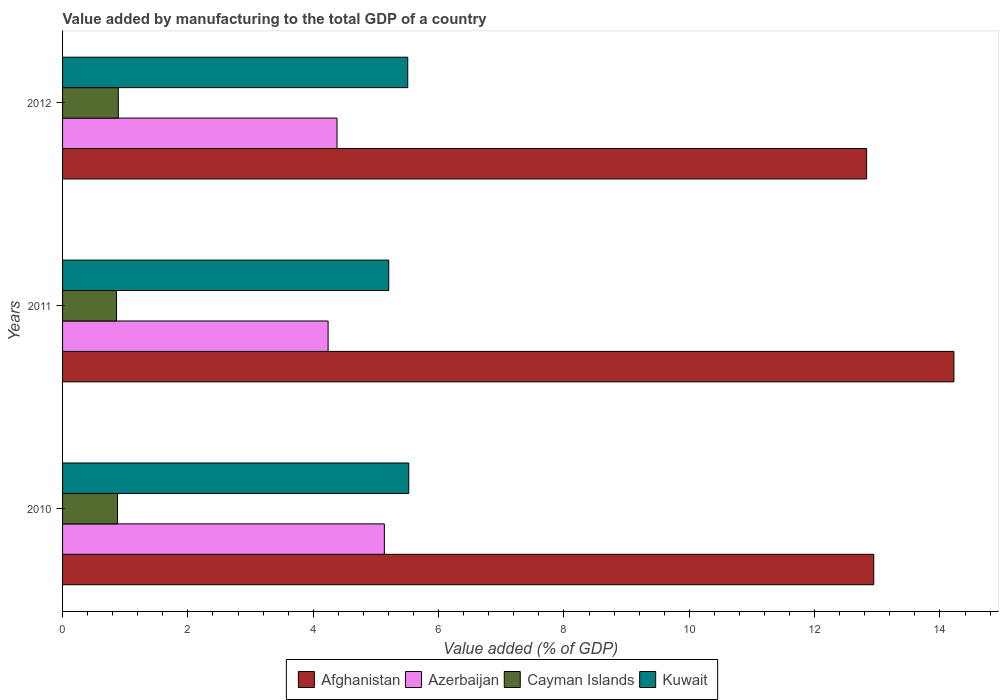How many different coloured bars are there?
Your answer should be very brief. 4. How many groups of bars are there?
Your answer should be very brief. 3. Are the number of bars per tick equal to the number of legend labels?
Your answer should be compact. Yes. Are the number of bars on each tick of the Y-axis equal?
Offer a terse response. Yes. How many bars are there on the 3rd tick from the top?
Give a very brief answer. 4. What is the label of the 1st group of bars from the top?
Provide a succinct answer. 2012. In how many cases, is the number of bars for a given year not equal to the number of legend labels?
Provide a succinct answer. 0. What is the value added by manufacturing to the total GDP in Cayman Islands in 2011?
Your response must be concise. 0.86. Across all years, what is the maximum value added by manufacturing to the total GDP in Kuwait?
Keep it short and to the point. 5.52. Across all years, what is the minimum value added by manufacturing to the total GDP in Kuwait?
Ensure brevity in your answer.  5.2. In which year was the value added by manufacturing to the total GDP in Cayman Islands maximum?
Give a very brief answer. 2012. What is the total value added by manufacturing to the total GDP in Azerbaijan in the graph?
Make the answer very short. 13.75. What is the difference between the value added by manufacturing to the total GDP in Cayman Islands in 2011 and that in 2012?
Your response must be concise. -0.03. What is the difference between the value added by manufacturing to the total GDP in Afghanistan in 2011 and the value added by manufacturing to the total GDP in Azerbaijan in 2012?
Offer a very short reply. 9.84. What is the average value added by manufacturing to the total GDP in Kuwait per year?
Provide a short and direct response. 5.41. In the year 2012, what is the difference between the value added by manufacturing to the total GDP in Afghanistan and value added by manufacturing to the total GDP in Cayman Islands?
Your answer should be very brief. 11.94. What is the ratio of the value added by manufacturing to the total GDP in Azerbaijan in 2010 to that in 2011?
Your answer should be compact. 1.21. Is the value added by manufacturing to the total GDP in Azerbaijan in 2010 less than that in 2012?
Provide a succinct answer. No. What is the difference between the highest and the second highest value added by manufacturing to the total GDP in Cayman Islands?
Make the answer very short. 0.01. What is the difference between the highest and the lowest value added by manufacturing to the total GDP in Kuwait?
Your answer should be very brief. 0.32. In how many years, is the value added by manufacturing to the total GDP in Kuwait greater than the average value added by manufacturing to the total GDP in Kuwait taken over all years?
Your answer should be compact. 2. Is it the case that in every year, the sum of the value added by manufacturing to the total GDP in Cayman Islands and value added by manufacturing to the total GDP in Kuwait is greater than the sum of value added by manufacturing to the total GDP in Afghanistan and value added by manufacturing to the total GDP in Azerbaijan?
Offer a terse response. Yes. What does the 3rd bar from the top in 2010 represents?
Your answer should be compact. Azerbaijan. What does the 3rd bar from the bottom in 2010 represents?
Your answer should be compact. Cayman Islands. Are all the bars in the graph horizontal?
Your answer should be compact. Yes. What is the difference between two consecutive major ticks on the X-axis?
Provide a short and direct response. 2. Are the values on the major ticks of X-axis written in scientific E-notation?
Your answer should be compact. No. Where does the legend appear in the graph?
Give a very brief answer. Bottom center. How are the legend labels stacked?
Your answer should be compact. Horizontal. What is the title of the graph?
Your response must be concise. Value added by manufacturing to the total GDP of a country. Does "Saudi Arabia" appear as one of the legend labels in the graph?
Your answer should be compact. No. What is the label or title of the X-axis?
Provide a short and direct response. Value added (% of GDP). What is the label or title of the Y-axis?
Your answer should be compact. Years. What is the Value added (% of GDP) in Afghanistan in 2010?
Offer a terse response. 12.94. What is the Value added (% of GDP) in Azerbaijan in 2010?
Your answer should be compact. 5.13. What is the Value added (% of GDP) of Cayman Islands in 2010?
Offer a terse response. 0.88. What is the Value added (% of GDP) in Kuwait in 2010?
Give a very brief answer. 5.52. What is the Value added (% of GDP) of Afghanistan in 2011?
Keep it short and to the point. 14.22. What is the Value added (% of GDP) of Azerbaijan in 2011?
Your response must be concise. 4.24. What is the Value added (% of GDP) in Cayman Islands in 2011?
Your answer should be compact. 0.86. What is the Value added (% of GDP) of Kuwait in 2011?
Offer a very short reply. 5.2. What is the Value added (% of GDP) in Afghanistan in 2012?
Your answer should be compact. 12.83. What is the Value added (% of GDP) of Azerbaijan in 2012?
Offer a terse response. 4.38. What is the Value added (% of GDP) of Cayman Islands in 2012?
Offer a terse response. 0.89. What is the Value added (% of GDP) of Kuwait in 2012?
Provide a short and direct response. 5.51. Across all years, what is the maximum Value added (% of GDP) of Afghanistan?
Keep it short and to the point. 14.22. Across all years, what is the maximum Value added (% of GDP) in Azerbaijan?
Provide a succinct answer. 5.13. Across all years, what is the maximum Value added (% of GDP) in Cayman Islands?
Your response must be concise. 0.89. Across all years, what is the maximum Value added (% of GDP) in Kuwait?
Ensure brevity in your answer.  5.52. Across all years, what is the minimum Value added (% of GDP) in Afghanistan?
Keep it short and to the point. 12.83. Across all years, what is the minimum Value added (% of GDP) in Azerbaijan?
Your answer should be compact. 4.24. Across all years, what is the minimum Value added (% of GDP) of Cayman Islands?
Provide a succinct answer. 0.86. Across all years, what is the minimum Value added (% of GDP) of Kuwait?
Offer a terse response. 5.2. What is the total Value added (% of GDP) in Afghanistan in the graph?
Your answer should be very brief. 40. What is the total Value added (% of GDP) of Azerbaijan in the graph?
Your answer should be very brief. 13.75. What is the total Value added (% of GDP) in Cayman Islands in the graph?
Provide a short and direct response. 2.63. What is the total Value added (% of GDP) in Kuwait in the graph?
Offer a terse response. 16.24. What is the difference between the Value added (% of GDP) of Afghanistan in 2010 and that in 2011?
Provide a succinct answer. -1.28. What is the difference between the Value added (% of GDP) in Azerbaijan in 2010 and that in 2011?
Your response must be concise. 0.9. What is the difference between the Value added (% of GDP) in Cayman Islands in 2010 and that in 2011?
Ensure brevity in your answer.  0.02. What is the difference between the Value added (% of GDP) of Kuwait in 2010 and that in 2011?
Your answer should be very brief. 0.32. What is the difference between the Value added (% of GDP) in Afghanistan in 2010 and that in 2012?
Your response must be concise. 0.11. What is the difference between the Value added (% of GDP) of Azerbaijan in 2010 and that in 2012?
Your answer should be very brief. 0.76. What is the difference between the Value added (% of GDP) in Cayman Islands in 2010 and that in 2012?
Your answer should be compact. -0.01. What is the difference between the Value added (% of GDP) of Kuwait in 2010 and that in 2012?
Your answer should be very brief. 0.02. What is the difference between the Value added (% of GDP) in Afghanistan in 2011 and that in 2012?
Provide a succinct answer. 1.39. What is the difference between the Value added (% of GDP) of Azerbaijan in 2011 and that in 2012?
Provide a short and direct response. -0.14. What is the difference between the Value added (% of GDP) in Cayman Islands in 2011 and that in 2012?
Offer a very short reply. -0.03. What is the difference between the Value added (% of GDP) of Kuwait in 2011 and that in 2012?
Offer a terse response. -0.3. What is the difference between the Value added (% of GDP) in Afghanistan in 2010 and the Value added (% of GDP) in Azerbaijan in 2011?
Offer a very short reply. 8.71. What is the difference between the Value added (% of GDP) of Afghanistan in 2010 and the Value added (% of GDP) of Cayman Islands in 2011?
Ensure brevity in your answer.  12.08. What is the difference between the Value added (% of GDP) in Afghanistan in 2010 and the Value added (% of GDP) in Kuwait in 2011?
Offer a terse response. 7.74. What is the difference between the Value added (% of GDP) of Azerbaijan in 2010 and the Value added (% of GDP) of Cayman Islands in 2011?
Your response must be concise. 4.27. What is the difference between the Value added (% of GDP) of Azerbaijan in 2010 and the Value added (% of GDP) of Kuwait in 2011?
Ensure brevity in your answer.  -0.07. What is the difference between the Value added (% of GDP) of Cayman Islands in 2010 and the Value added (% of GDP) of Kuwait in 2011?
Your response must be concise. -4.33. What is the difference between the Value added (% of GDP) in Afghanistan in 2010 and the Value added (% of GDP) in Azerbaijan in 2012?
Offer a terse response. 8.56. What is the difference between the Value added (% of GDP) in Afghanistan in 2010 and the Value added (% of GDP) in Cayman Islands in 2012?
Make the answer very short. 12.05. What is the difference between the Value added (% of GDP) of Afghanistan in 2010 and the Value added (% of GDP) of Kuwait in 2012?
Your response must be concise. 7.44. What is the difference between the Value added (% of GDP) in Azerbaijan in 2010 and the Value added (% of GDP) in Cayman Islands in 2012?
Give a very brief answer. 4.25. What is the difference between the Value added (% of GDP) in Azerbaijan in 2010 and the Value added (% of GDP) in Kuwait in 2012?
Provide a short and direct response. -0.37. What is the difference between the Value added (% of GDP) of Cayman Islands in 2010 and the Value added (% of GDP) of Kuwait in 2012?
Your answer should be compact. -4.63. What is the difference between the Value added (% of GDP) of Afghanistan in 2011 and the Value added (% of GDP) of Azerbaijan in 2012?
Your response must be concise. 9.84. What is the difference between the Value added (% of GDP) of Afghanistan in 2011 and the Value added (% of GDP) of Cayman Islands in 2012?
Offer a terse response. 13.33. What is the difference between the Value added (% of GDP) in Afghanistan in 2011 and the Value added (% of GDP) in Kuwait in 2012?
Provide a short and direct response. 8.71. What is the difference between the Value added (% of GDP) of Azerbaijan in 2011 and the Value added (% of GDP) of Cayman Islands in 2012?
Ensure brevity in your answer.  3.35. What is the difference between the Value added (% of GDP) of Azerbaijan in 2011 and the Value added (% of GDP) of Kuwait in 2012?
Keep it short and to the point. -1.27. What is the difference between the Value added (% of GDP) of Cayman Islands in 2011 and the Value added (% of GDP) of Kuwait in 2012?
Keep it short and to the point. -4.65. What is the average Value added (% of GDP) of Afghanistan per year?
Provide a short and direct response. 13.33. What is the average Value added (% of GDP) of Azerbaijan per year?
Your answer should be very brief. 4.58. What is the average Value added (% of GDP) of Cayman Islands per year?
Ensure brevity in your answer.  0.88. What is the average Value added (% of GDP) in Kuwait per year?
Your response must be concise. 5.41. In the year 2010, what is the difference between the Value added (% of GDP) in Afghanistan and Value added (% of GDP) in Azerbaijan?
Your response must be concise. 7.81. In the year 2010, what is the difference between the Value added (% of GDP) in Afghanistan and Value added (% of GDP) in Cayman Islands?
Offer a very short reply. 12.07. In the year 2010, what is the difference between the Value added (% of GDP) of Afghanistan and Value added (% of GDP) of Kuwait?
Your response must be concise. 7.42. In the year 2010, what is the difference between the Value added (% of GDP) of Azerbaijan and Value added (% of GDP) of Cayman Islands?
Give a very brief answer. 4.26. In the year 2010, what is the difference between the Value added (% of GDP) of Azerbaijan and Value added (% of GDP) of Kuwait?
Ensure brevity in your answer.  -0.39. In the year 2010, what is the difference between the Value added (% of GDP) in Cayman Islands and Value added (% of GDP) in Kuwait?
Provide a succinct answer. -4.65. In the year 2011, what is the difference between the Value added (% of GDP) of Afghanistan and Value added (% of GDP) of Azerbaijan?
Keep it short and to the point. 9.99. In the year 2011, what is the difference between the Value added (% of GDP) of Afghanistan and Value added (% of GDP) of Cayman Islands?
Provide a succinct answer. 13.36. In the year 2011, what is the difference between the Value added (% of GDP) in Afghanistan and Value added (% of GDP) in Kuwait?
Provide a succinct answer. 9.02. In the year 2011, what is the difference between the Value added (% of GDP) of Azerbaijan and Value added (% of GDP) of Cayman Islands?
Provide a short and direct response. 3.38. In the year 2011, what is the difference between the Value added (% of GDP) in Azerbaijan and Value added (% of GDP) in Kuwait?
Ensure brevity in your answer.  -0.97. In the year 2011, what is the difference between the Value added (% of GDP) in Cayman Islands and Value added (% of GDP) in Kuwait?
Give a very brief answer. -4.34. In the year 2012, what is the difference between the Value added (% of GDP) of Afghanistan and Value added (% of GDP) of Azerbaijan?
Provide a succinct answer. 8.45. In the year 2012, what is the difference between the Value added (% of GDP) in Afghanistan and Value added (% of GDP) in Cayman Islands?
Offer a terse response. 11.94. In the year 2012, what is the difference between the Value added (% of GDP) in Afghanistan and Value added (% of GDP) in Kuwait?
Provide a short and direct response. 7.32. In the year 2012, what is the difference between the Value added (% of GDP) in Azerbaijan and Value added (% of GDP) in Cayman Islands?
Provide a succinct answer. 3.49. In the year 2012, what is the difference between the Value added (% of GDP) in Azerbaijan and Value added (% of GDP) in Kuwait?
Ensure brevity in your answer.  -1.13. In the year 2012, what is the difference between the Value added (% of GDP) of Cayman Islands and Value added (% of GDP) of Kuwait?
Your answer should be compact. -4.62. What is the ratio of the Value added (% of GDP) of Afghanistan in 2010 to that in 2011?
Your answer should be compact. 0.91. What is the ratio of the Value added (% of GDP) in Azerbaijan in 2010 to that in 2011?
Keep it short and to the point. 1.21. What is the ratio of the Value added (% of GDP) in Cayman Islands in 2010 to that in 2011?
Your response must be concise. 1.02. What is the ratio of the Value added (% of GDP) of Kuwait in 2010 to that in 2011?
Your answer should be compact. 1.06. What is the ratio of the Value added (% of GDP) in Afghanistan in 2010 to that in 2012?
Offer a very short reply. 1.01. What is the ratio of the Value added (% of GDP) of Azerbaijan in 2010 to that in 2012?
Keep it short and to the point. 1.17. What is the ratio of the Value added (% of GDP) of Cayman Islands in 2010 to that in 2012?
Offer a terse response. 0.99. What is the ratio of the Value added (% of GDP) in Kuwait in 2010 to that in 2012?
Provide a short and direct response. 1. What is the ratio of the Value added (% of GDP) of Afghanistan in 2011 to that in 2012?
Ensure brevity in your answer.  1.11. What is the ratio of the Value added (% of GDP) of Azerbaijan in 2011 to that in 2012?
Your response must be concise. 0.97. What is the ratio of the Value added (% of GDP) in Cayman Islands in 2011 to that in 2012?
Give a very brief answer. 0.97. What is the ratio of the Value added (% of GDP) of Kuwait in 2011 to that in 2012?
Keep it short and to the point. 0.94. What is the difference between the highest and the second highest Value added (% of GDP) of Afghanistan?
Provide a short and direct response. 1.28. What is the difference between the highest and the second highest Value added (% of GDP) in Azerbaijan?
Provide a succinct answer. 0.76. What is the difference between the highest and the second highest Value added (% of GDP) of Cayman Islands?
Your answer should be very brief. 0.01. What is the difference between the highest and the second highest Value added (% of GDP) in Kuwait?
Give a very brief answer. 0.02. What is the difference between the highest and the lowest Value added (% of GDP) of Afghanistan?
Keep it short and to the point. 1.39. What is the difference between the highest and the lowest Value added (% of GDP) of Azerbaijan?
Give a very brief answer. 0.9. What is the difference between the highest and the lowest Value added (% of GDP) of Cayman Islands?
Your answer should be very brief. 0.03. What is the difference between the highest and the lowest Value added (% of GDP) of Kuwait?
Provide a succinct answer. 0.32. 